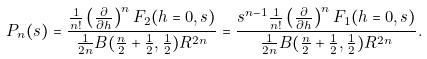Convert formula to latex. <formula><loc_0><loc_0><loc_500><loc_500>P _ { n } ( s ) = \frac { \frac { 1 } { n ! } \left ( \frac { \partial } { \partial h } \right ) ^ { n } F _ { 2 } ( h = 0 , s ) } { \frac { 1 } { 2 n } B ( \frac { n } { 2 } + \frac { 1 } { 2 } , \frac { 1 } { 2 } ) R ^ { 2 n } } = \frac { s ^ { n - 1 } \frac { 1 } { n ! } \left ( \frac { \partial } { \partial h } \right ) ^ { n } F _ { 1 } ( h = 0 , s ) } { \frac { 1 } { 2 n } B ( \frac { n } { 2 } + \frac { 1 } { 2 } , \frac { 1 } { 2 } ) R ^ { 2 n } } .</formula> 